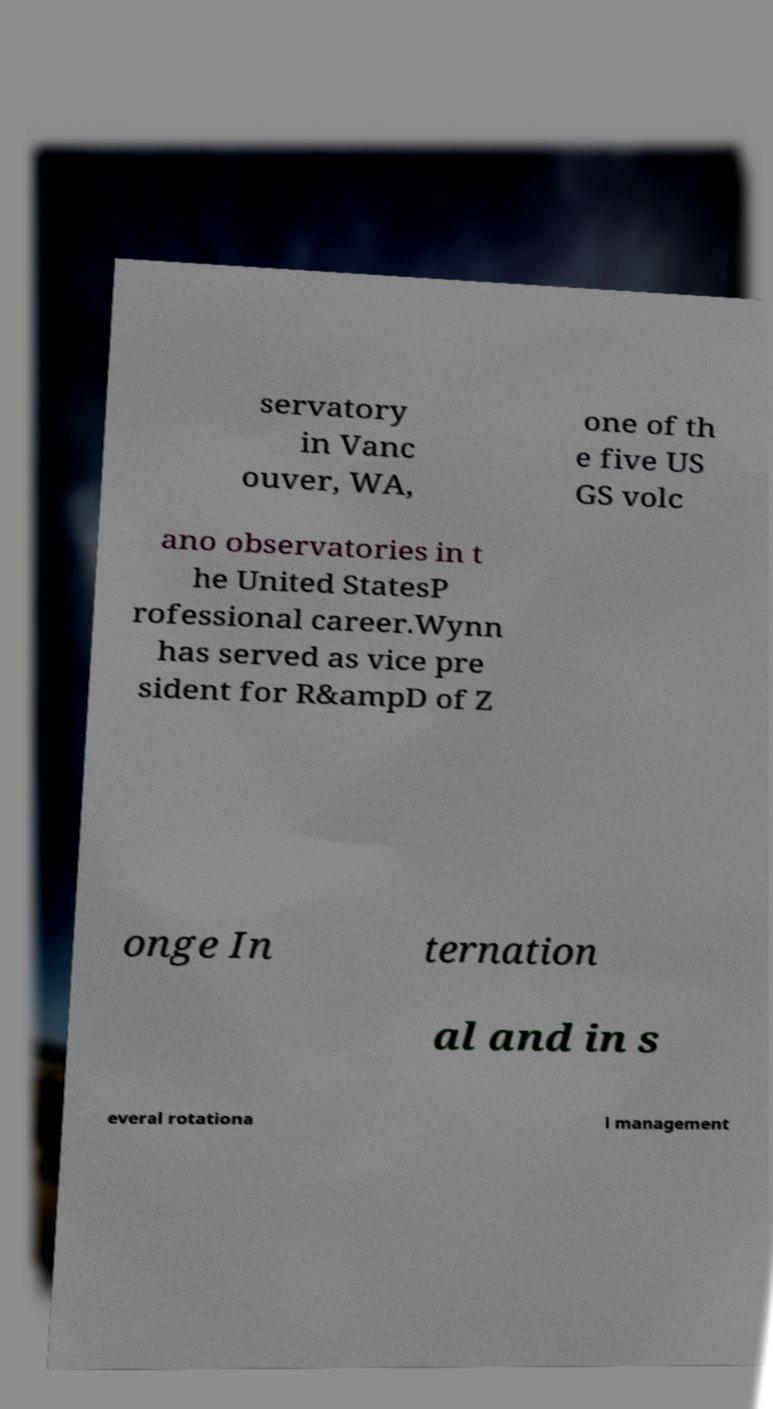For documentation purposes, I need the text within this image transcribed. Could you provide that? servatory in Vanc ouver, WA, one of th e five US GS volc ano observatories in t he United StatesP rofessional career.Wynn has served as vice pre sident for R&ampD of Z onge In ternation al and in s everal rotationa l management 